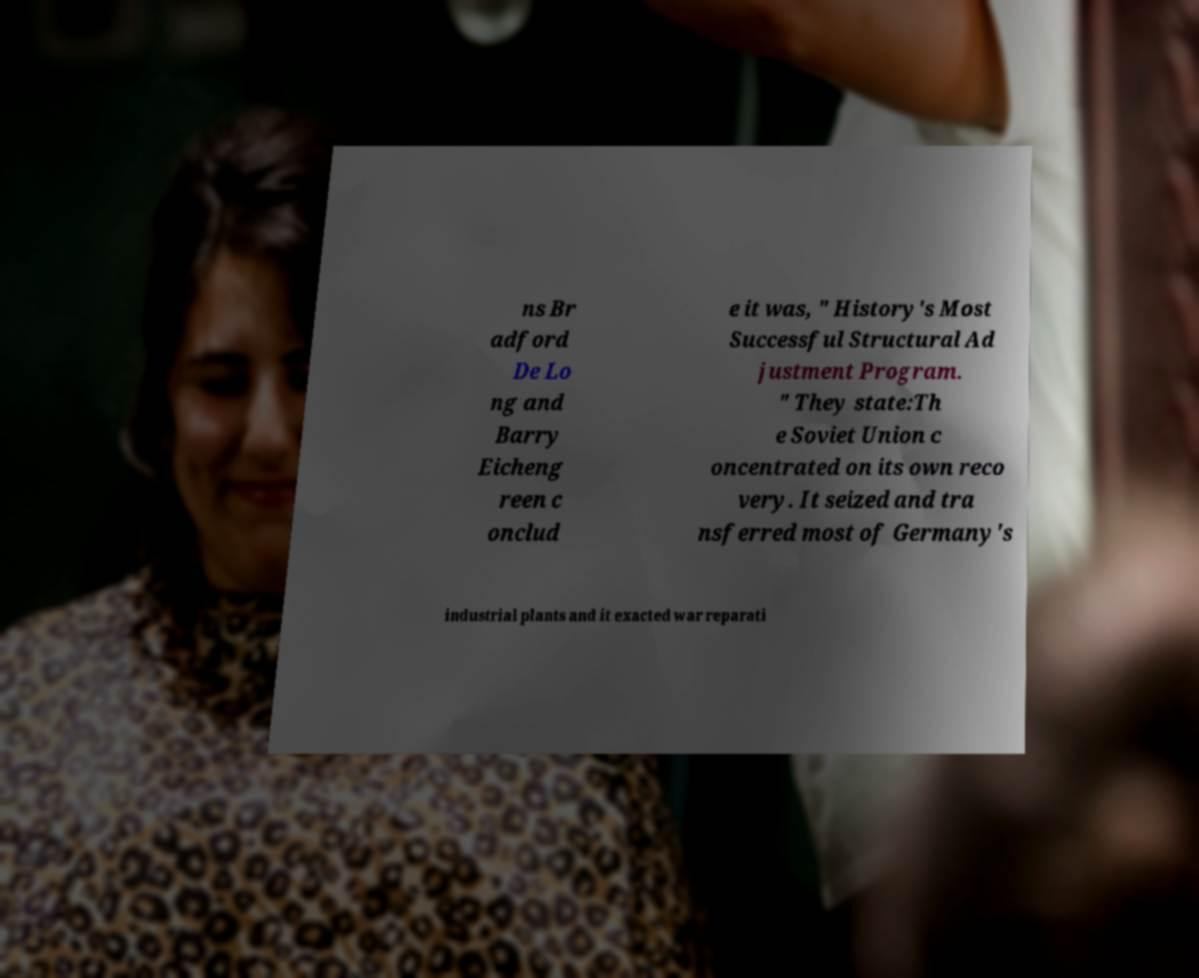I need the written content from this picture converted into text. Can you do that? ns Br adford De Lo ng and Barry Eicheng reen c onclud e it was, " History's Most Successful Structural Ad justment Program. " They state:Th e Soviet Union c oncentrated on its own reco very. It seized and tra nsferred most of Germany's industrial plants and it exacted war reparati 